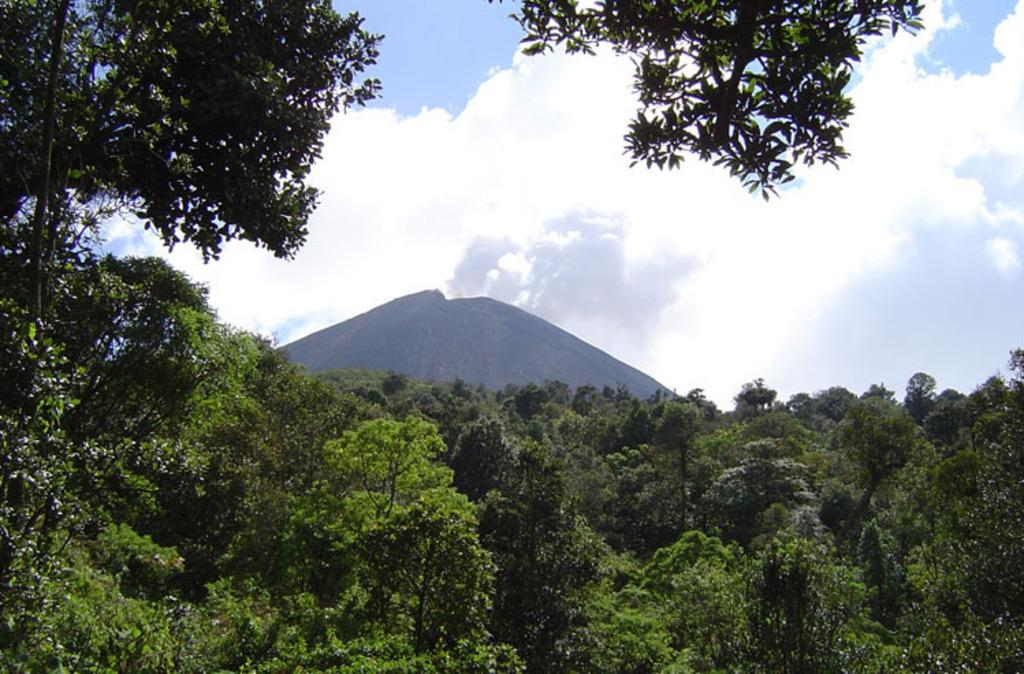What type of vegetation can be seen in the image? There are trees in the image. What geographical feature is present in the image? There is a hill in the image. What part of the natural environment is visible in the image? The sky is visible in the background of the image. What type of amusement can be seen on the hill in the image? There is no amusement present on the hill in the image; it is a natural geographical feature. What wish can be granted by the trees in the image? There is no wish-granting ability associated with the trees in the image; they are simply vegetation. 